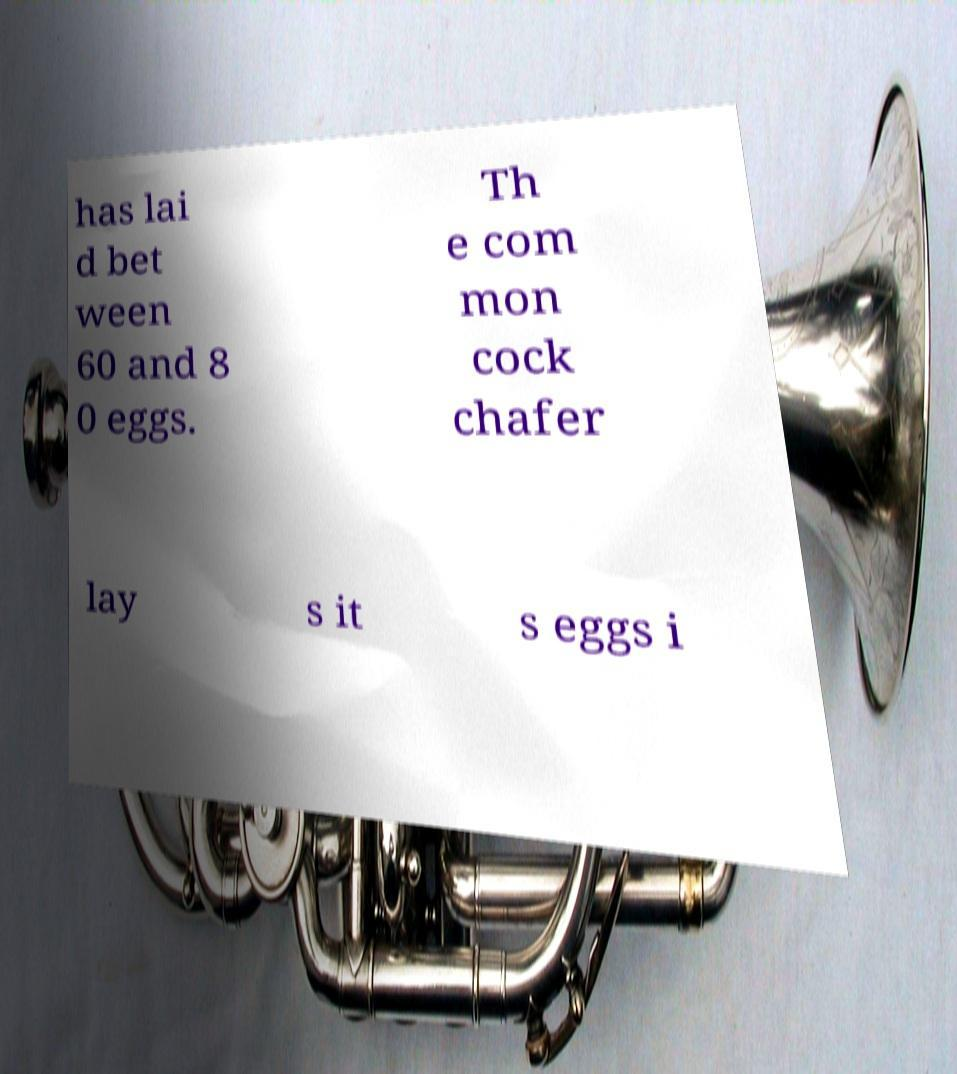Can you accurately transcribe the text from the provided image for me? has lai d bet ween 60 and 8 0 eggs. Th e com mon cock chafer lay s it s eggs i 